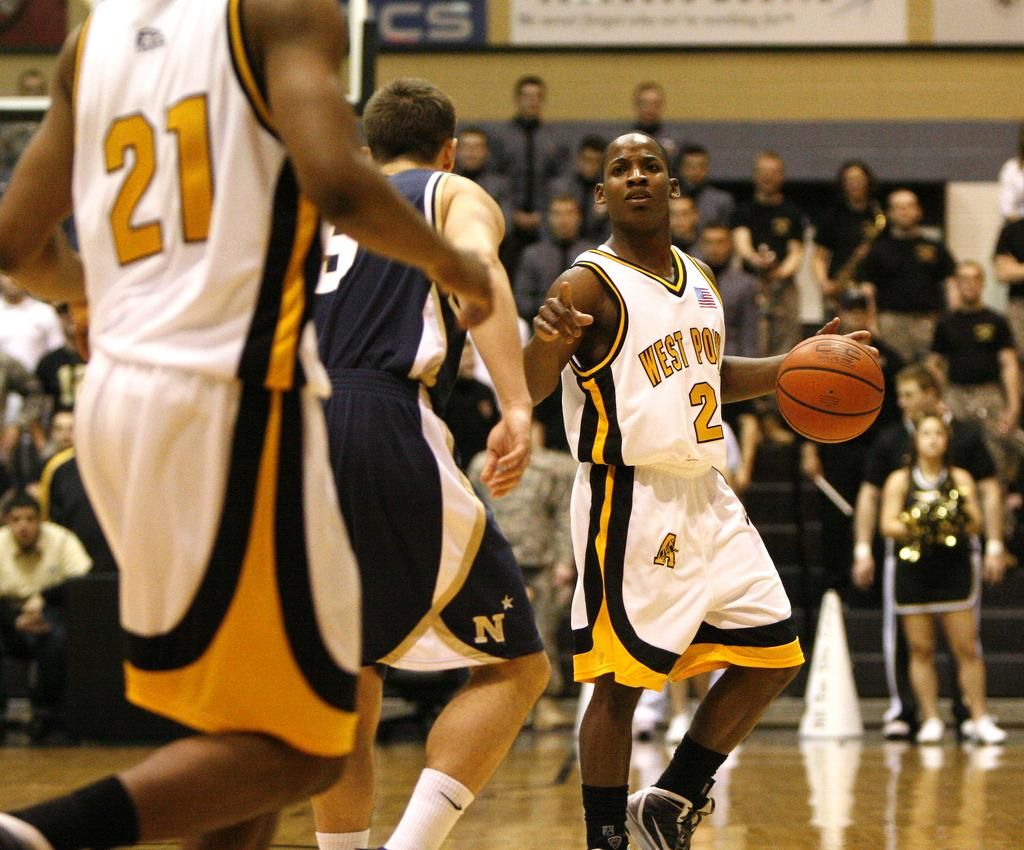<image>
Describe the image concisely. Player number 2 has the ball on the court. 